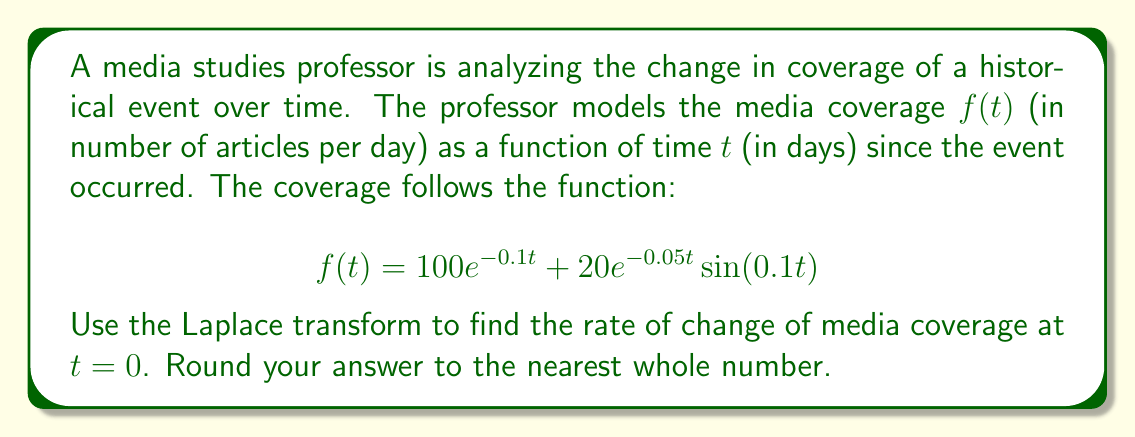Can you solve this math problem? To solve this problem, we'll follow these steps:

1) First, recall that the Laplace transform of the derivative of a function is given by:

   $$\mathcal{L}\{f'(t)\} = sF(s) - f(0)$$

   where $F(s)$ is the Laplace transform of $f(t)$.

2) We need to find $f'(0)$, which is equivalent to finding $\lim_{s \to \infty} [sF(s) - f(0)]$.

3) Let's start by finding $f(0)$:
   
   $$f(0) = 100e^{-0.1(0)} + 20e^{-0.05(0)}\sin(0.1(0)) = 100 + 0 = 100$$

4) Now, let's find $F(s)$. We can use the linearity property of Laplace transforms and transform each term separately:

   For $100e^{-0.1t}$: $\mathcal{L}\{100e^{-0.1t}\} = \frac{100}{s+0.1}$

   For $20e^{-0.05t}\sin(0.1t)$: $\mathcal{L}\{20e^{-0.05t}\sin(0.1t)\} = \frac{2}{(s+0.05)^2 + 0.1^2}$

   Therefore, $F(s) = \frac{100}{s+0.1} + \frac{2}{(s+0.05)^2 + 0.1^2}$

5) Now we can form the expression for $f'(t)$:

   $$\mathcal{L}\{f'(t)\} = sF(s) - f(0) = s\left(\frac{100}{s+0.1} + \frac{2}{(s+0.05)^2 + 0.1^2}\right) - 100$$

6) To find $f'(0)$, we need to evaluate the limit as $s$ approaches infinity:

   $$f'(0) = \lim_{s \to \infty} \left[s\left(\frac{100}{s+0.1} + \frac{2}{(s+0.05)^2 + 0.1^2}\right) - 100\right]$$

7) As $s$ approaches infinity, the second term in the parentheses approaches zero faster than the first term. So we can simplify:

   $$f'(0) = \lim_{s \to \infty} \left[\frac{100s}{s+0.1} - 100\right] = 100 \cdot 1 - 100 = 0 - 100 = -10$$

8) Rounding to the nearest whole number, we get -10.
Answer: $-10$ articles per day 